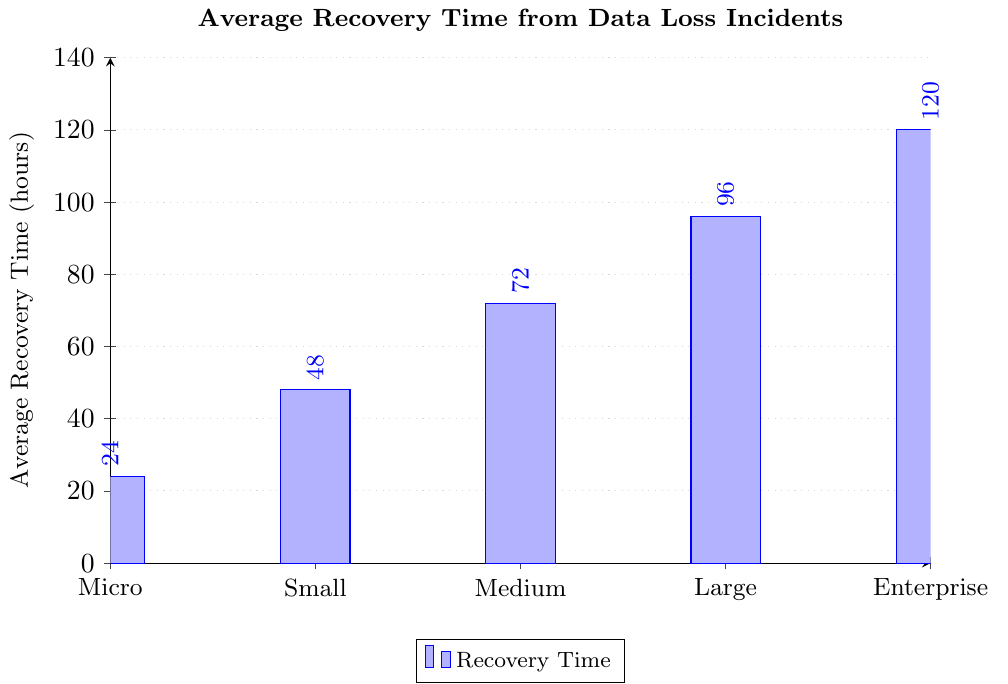What is the average recovery time for small businesses? The average recovery time for small businesses can be directly retrieved from the plot where the bar labeled "Small" reaches a height that corresponds to the y-axis value. In this case, the height of the "Small" bar is at 48 hours.
Answer: 48 hours Which business size has the longest average recovery time? To determine this, we compare the heights of all the bars in the plot. The "Enterprise" bar reaches the highest value on the y-axis, indicating the longest average recovery time.
Answer: Enterprise How many more hours does it take for a large business to recover compared to a micro business? The recovery time for a large business is 96 hours and for a micro business, it is 24 hours. Subtracting these values gives 96 - 24 = 72 hours.
Answer: 72 hours What is the total average recovery time for micro, small, and medium businesses? Add the values for micro (24 hours), small (48 hours), and medium (72 hours) businesses: 24 + 48 + 72 = 144 hours.
Answer: 144 hours Is the average recovery time for medium businesses more than twice that of micro businesses? Calculate twice the recovery time for micro businesses: 24 * 2 = 48 hours. Compare this to the medium business recovery time of 72 hours. Since 72 > 48, the answer is yes.
Answer: Yes Rank the business sizes from shortest to longest average recovery time. By examining the heights of the bars from shortest to tallest, the ranking is: Micro, Small, Medium, Large, Enterprise.
Answer: Micro, Small, Medium, Large, Enterprise What are the average recovery times for businesses with more than 50 but less than 1000 employees? This includes medium and large businesses. From the plot, medium businesses' recovery time is 72 hours, and large businesses' recovery time is 96 hours.
Answer: 72 hours and 96 hours Which business size has an average recovery time closer to the overall mean recovery time of all sizes? First, calculate the mean recovery time: (24 + 48 + 72 + 96 + 120) / 5 = 72 hours. Compare each business size's recovery time to 72 hours. Medium business also has a recovery time of 72 hours, which is exactly the mean.
Answer: Medium How much longer is the average recovery time for enterprise businesses compared to small businesses? The average recovery time for enterprise businesses is 120 hours, and for small businesses, it is 48 hours. Subtract the smaller value from the larger value: 120 - 48 = 72 hours.
Answer: 72 hours 